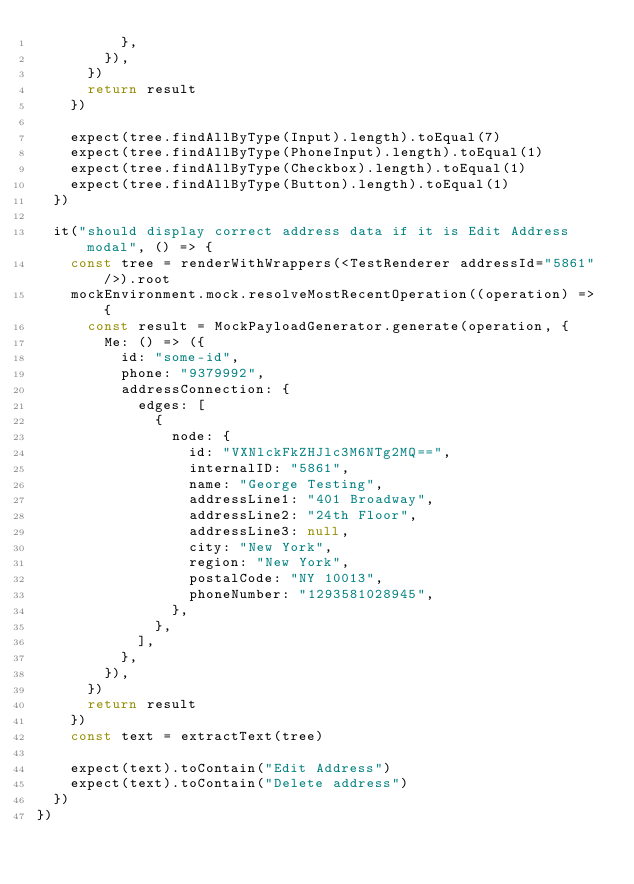Convert code to text. <code><loc_0><loc_0><loc_500><loc_500><_TypeScript_>          },
        }),
      })
      return result
    })

    expect(tree.findAllByType(Input).length).toEqual(7)
    expect(tree.findAllByType(PhoneInput).length).toEqual(1)
    expect(tree.findAllByType(Checkbox).length).toEqual(1)
    expect(tree.findAllByType(Button).length).toEqual(1)
  })

  it("should display correct address data if it is Edit Address modal", () => {
    const tree = renderWithWrappers(<TestRenderer addressId="5861" />).root
    mockEnvironment.mock.resolveMostRecentOperation((operation) => {
      const result = MockPayloadGenerator.generate(operation, {
        Me: () => ({
          id: "some-id",
          phone: "9379992",
          addressConnection: {
            edges: [
              {
                node: {
                  id: "VXNlckFkZHJlc3M6NTg2MQ==",
                  internalID: "5861",
                  name: "George Testing",
                  addressLine1: "401 Broadway",
                  addressLine2: "24th Floor",
                  addressLine3: null,
                  city: "New York",
                  region: "New York",
                  postalCode: "NY 10013",
                  phoneNumber: "1293581028945",
                },
              },
            ],
          },
        }),
      })
      return result
    })
    const text = extractText(tree)

    expect(text).toContain("Edit Address")
    expect(text).toContain("Delete address")
  })
})
</code> 